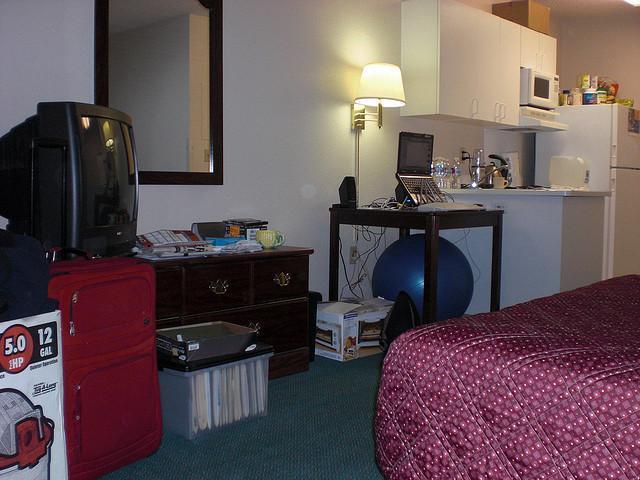How many beds are there?
Give a very brief answer. 1. 